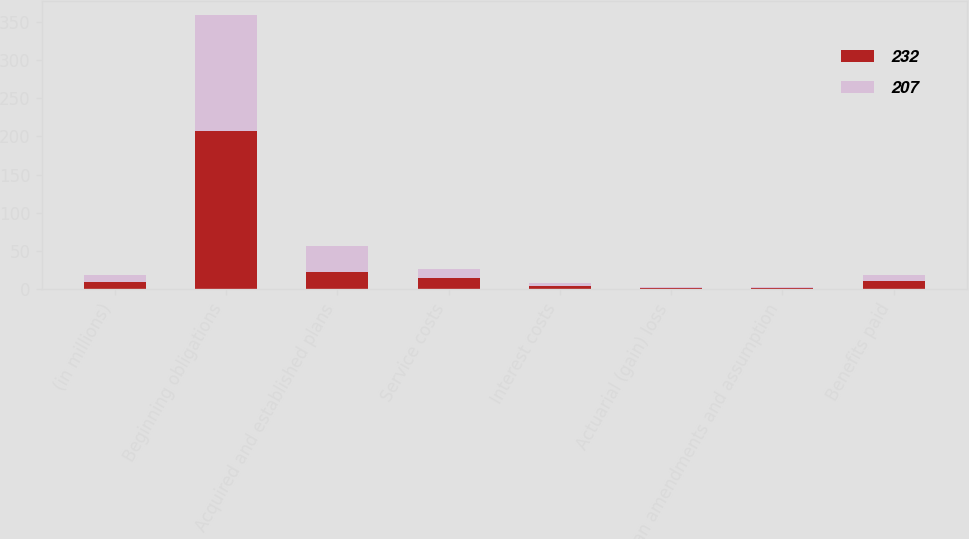Convert chart. <chart><loc_0><loc_0><loc_500><loc_500><stacked_bar_chart><ecel><fcel>(in millions)<fcel>Beginning obligations<fcel>Acquired and established plans<fcel>Service costs<fcel>Interest costs<fcel>Actuarial (gain) loss<fcel>Plan amendments and assumption<fcel>Benefits paid<nl><fcel>232<fcel>9<fcel>207<fcel>23<fcel>14<fcel>4<fcel>1<fcel>2<fcel>10<nl><fcel>207<fcel>9<fcel>152<fcel>33<fcel>13<fcel>4<fcel>2<fcel>1<fcel>8<nl></chart> 